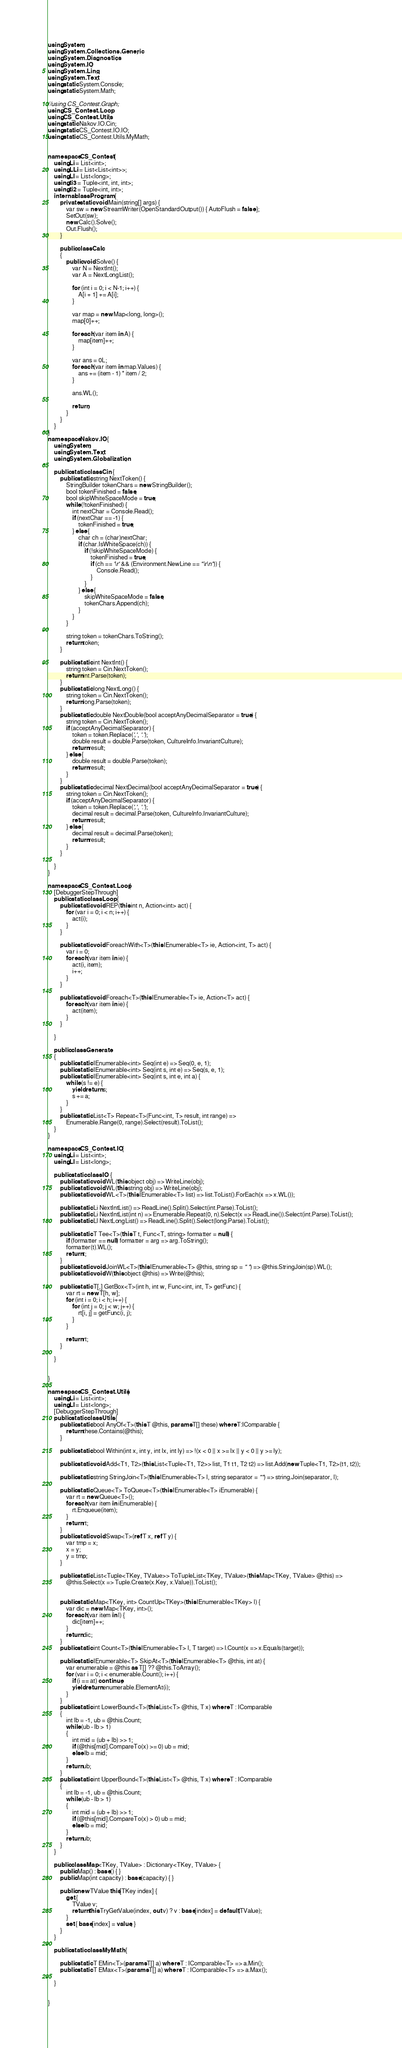Convert code to text. <code><loc_0><loc_0><loc_500><loc_500><_C#_>using System;
using System.Collections.Generic;
using System.Diagnostics;
using System.IO;
using System.Linq;
using System.Text;
using static System.Console;
using static System.Math;

//using CS_Contest.Graph;
using CS_Contest.Loop;
using CS_Contest.Utils;
using static Nakov.IO.Cin;
using static CS_Contest.IO.IO;
using static CS_Contest.Utils.MyMath;


namespace CS_Contest {
	using Li = List<int>;
	using LLi = List<List<int>>;
	using Ll = List<long>;
	using ti3 = Tuple<int, int, int>;
	using ti2 = Tuple<int, int>;
	internal class Program {
		private static void Main(string[] args) {
			var sw = new StreamWriter(OpenStandardOutput()) { AutoFlush = false };
			SetOut(sw);
			new Calc().Solve();
			Out.Flush();
		}

	    public class Calc
	    {
	        public void Solve() {
	            var N = NextInt();
	            var A = NextLongList();

	            for (int i = 0; i < N-1; i++) {
	                A[i + 1] += A[i];
	            }

	            var map = new Map<long, long>();
	            map[0]++;

	            foreach (var item in A) {
	                map[item]++;
	            }

	            var ans = 0L;
	            foreach (var item in map.Values) {
	                ans += (item - 1) * item / 2;
	            }

                ans.WL();
                
                return;
	        }
        }
    }
}
namespace Nakov.IO {
	using System;
	using System.Text;
	using System.Globalization;

	public static class Cin {
		public static string NextToken() {
			StringBuilder tokenChars = new StringBuilder();
			bool tokenFinished = false;
			bool skipWhiteSpaceMode = true;
			while (!tokenFinished) {
				int nextChar = Console.Read();
				if (nextChar == -1) {
					tokenFinished = true;
				} else {
					char ch = (char)nextChar;
					if (char.IsWhiteSpace(ch)) {
						if (!skipWhiteSpaceMode) {
							tokenFinished = true;
							if (ch == '\r' && (Environment.NewLine == "\r\n")) {
								Console.Read();
							}
						}
					} else {
						skipWhiteSpaceMode = false;
						tokenChars.Append(ch);
					}
				}
			}

			string token = tokenChars.ToString();
			return token;
		}

		public static int NextInt() {
			string token = Cin.NextToken();
			return int.Parse(token);
		}
		public static long NextLong() {
			string token = Cin.NextToken();
			return long.Parse(token);
		}
		public static double NextDouble(bool acceptAnyDecimalSeparator = true) {
			string token = Cin.NextToken();
			if (acceptAnyDecimalSeparator) {
				token = token.Replace(',', '.');
				double result = double.Parse(token, CultureInfo.InvariantCulture);
				return result;
			} else {
				double result = double.Parse(token);
				return result;
			}
		}
		public static decimal NextDecimal(bool acceptAnyDecimalSeparator = true) {
			string token = Cin.NextToken();
			if (acceptAnyDecimalSeparator) {
				token = token.Replace(',', '.');
				decimal result = decimal.Parse(token, CultureInfo.InvariantCulture);
				return result;
			} else {
				decimal result = decimal.Parse(token);
				return result;
			}
		}

	}
}

namespace CS_Contest.Loop {
	[DebuggerStepThrough]
	public static class Loop {
		public static void REP(this int n, Action<int> act) {
			for (var i = 0; i < n; i++) {
				act(i);
			}
		}

		public static void ForeachWith<T>(this IEnumerable<T> ie, Action<int, T> act) {
			var i = 0;
			foreach (var item in ie) {
				act(i, item);
				i++;
			}
		}

		public static void Foreach<T>(this IEnumerable<T> ie, Action<T> act) {
			foreach (var item in ie) {
				act(item);
			}
		}

	}

	public class Generate
	{
	    public static IEnumerable<int> Seq(int e) => Seq(0, e, 1);
		public static IEnumerable<int> Seq(int s, int e) => Seq(s, e, 1);
		public static IEnumerable<int> Seq(int s, int e, int a) {
			while (s != e) {
				yield return s;
				s += a;
			}
		}
		public static List<T> Repeat<T>(Func<int, T> result, int range) =>
			Enumerable.Range(0, range).Select(result).ToList();
	}
}

namespace CS_Contest.IO {
	using Li = List<int>;
	using Ll = List<long>;

	public static class IO {
		public static void WL(this object obj) => WriteLine(obj);
		public static void WL(this string obj) => WriteLine(obj);
		public static void WL<T>(this IEnumerable<T> list) => list.ToList().ForEach(x => x.WL());

		public static Li NextIntList() => ReadLine().Split().Select(int.Parse).ToList();
		public static Li NextIntList(int n) => Enumerable.Repeat(0, n).Select(x => ReadLine()).Select(int.Parse).ToList();
		public static Ll NextLongList() => ReadLine().Split().Select(long.Parse).ToList();

		public static T Tee<T>(this T t, Func<T, string> formatter = null) {
			if (formatter == null) formatter = arg => arg.ToString();
			formatter(t).WL();
			return t;
		}
		public static void JoinWL<T>(this IEnumerable<T> @this, string sp = " ") => @this.StringJoin(sp).WL();
		public static void W(this object @this) => Write(@this);

	    public static T[,] GetBox<T>(int h, int w, Func<int, int, T> getFunc) {
	        var rt = new T[h, w];
	        for (int i = 0; i < h; i++) {
	            for (int j = 0; j < w; j++) {
	                rt[i, j] = getFunc(i, j);
	            }
	        }

	        return rt;
	    }

	}


}

namespace CS_Contest.Utils {
	using Li = List<int>;
	using Ll = List<long>;
	[DebuggerStepThrough]
	public static class Utils {
	    public static bool AnyOf<T>(this T @this, params T[] these) where T:IComparable {
	        return these.Contains(@this);
	    }

		public static bool Within(int x, int y, int lx, int ly) => !(x < 0 || x >= lx || y < 0 || y >= ly);

		public static void Add<T1, T2>(this List<Tuple<T1, T2>> list, T1 t1, T2 t2) => list.Add(new Tuple<T1, T2>(t1, t2));

		public static string StringJoin<T>(this IEnumerable<T> l, string separator = "") => string.Join(separator, l);

		public static Queue<T> ToQueue<T>(this IEnumerable<T> iEnumerable) {
			var rt = new Queue<T>();
			foreach (var item in iEnumerable) {
				rt.Enqueue(item);
			}
			return rt;
		}
		public static void Swap<T>(ref T x, ref T y) {
			var tmp = x;
			x = y;
			y = tmp;
		}

	    public static List<Tuple<TKey, TValue>> ToTupleList<TKey, TValue>(this Map<TKey, TValue> @this) =>
	        @this.Select(x => Tuple.Create(x.Key, x.Value)).ToList();


		public static Map<TKey, int> CountUp<TKey>(this IEnumerable<TKey> l) {
			var dic = new Map<TKey, int>();
			foreach (var item in l) {
			    dic[item]++;
			}
			return dic;
		}
		public static int Count<T>(this IEnumerable<T> l, T target) => l.Count(x => x.Equals(target));

		public static IEnumerable<T> SkipAt<T>(this IEnumerable<T> @this, int at) {
			var enumerable = @this as T[] ?? @this.ToArray();
			for (var i = 0; i < enumerable.Count(); i++) {
				if (i == at) continue;
				yield return enumerable.ElementAt(i);
			}
		}
	    public static int LowerBound<T>(this List<T> @this, T x) where T : IComparable
	    {
            int lb = -1, ub = @this.Count;
	        while (ub - lb > 1)
	        {
	            int mid = (ub + lb) >> 1;
	            if (@this[mid].CompareTo(x) >= 0) ub = mid;
	            else lb = mid;
	        }
	        return ub;
	    }
	    public static int UpperBound<T>(this List<T> @this, T x) where T : IComparable
	    {
	        int lb = -1, ub = @this.Count;
	        while (ub - lb > 1)
	        {
	            int mid = (ub + lb) >> 1;
	            if (@this[mid].CompareTo(x) > 0) ub = mid;
	            else lb = mid;
	        }
	        return ub;
	    }
    }

	public class Map<TKey, TValue> : Dictionary<TKey, TValue> {
		public Map() : base() { }
		public Map(int capacity) : base(capacity) { }

		public new TValue this[TKey index] {
			get {
				TValue v;
				return this.TryGetValue(index, out v) ? v : base[index] = default(TValue);
			}
			set { base[index] = value; }
		}
	}

	public static class MyMath {
		
		public static T EMin<T>(params T[] a) where T : IComparable<T> => a.Min();
		public static T EMax<T>(params T[] a) where T : IComparable<T> => a.Max();

	}


}

</code> 